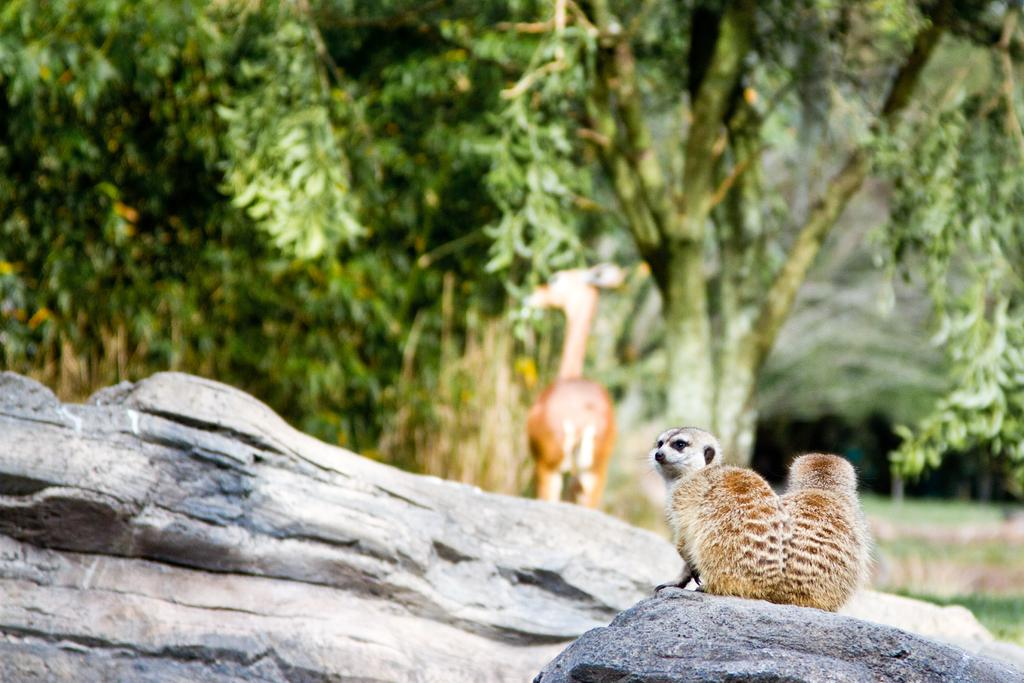What types of living organisms can be seen in the image? There are animals in the image. What can be seen in the background of the image? There are trees in the background of the image. What type of natural features are present at the bottom of the image? There are rocks at the bottom of the image. What type of school can be seen in the image? There is no school present in the image; it features animals, trees, and rocks. Are the animals in the image engaged in a fight? There is no indication of a fight between the animals in the image. 